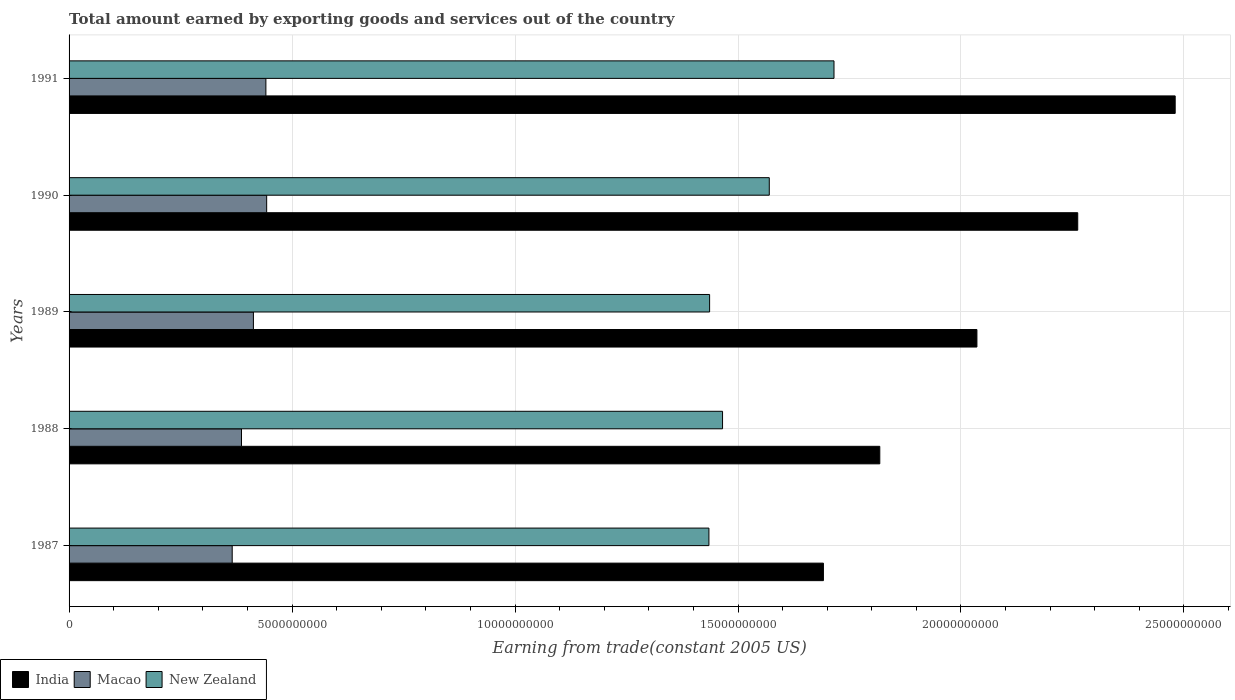How many different coloured bars are there?
Your response must be concise. 3. How many groups of bars are there?
Provide a short and direct response. 5. How many bars are there on the 3rd tick from the bottom?
Ensure brevity in your answer.  3. What is the total amount earned by exporting goods and services in Macao in 1989?
Your answer should be very brief. 4.13e+09. Across all years, what is the maximum total amount earned by exporting goods and services in Macao?
Make the answer very short. 4.43e+09. Across all years, what is the minimum total amount earned by exporting goods and services in New Zealand?
Make the answer very short. 1.43e+1. In which year was the total amount earned by exporting goods and services in Macao maximum?
Keep it short and to the point. 1990. In which year was the total amount earned by exporting goods and services in New Zealand minimum?
Offer a very short reply. 1987. What is the total total amount earned by exporting goods and services in Macao in the graph?
Give a very brief answer. 2.05e+1. What is the difference between the total amount earned by exporting goods and services in India in 1987 and that in 1990?
Keep it short and to the point. -5.70e+09. What is the difference between the total amount earned by exporting goods and services in Macao in 1991 and the total amount earned by exporting goods and services in New Zealand in 1989?
Your response must be concise. -9.95e+09. What is the average total amount earned by exporting goods and services in New Zealand per year?
Your answer should be compact. 1.52e+1. In the year 1987, what is the difference between the total amount earned by exporting goods and services in New Zealand and total amount earned by exporting goods and services in Macao?
Provide a short and direct response. 1.07e+1. What is the ratio of the total amount earned by exporting goods and services in New Zealand in 1989 to that in 1991?
Ensure brevity in your answer.  0.84. Is the total amount earned by exporting goods and services in India in 1987 less than that in 1989?
Provide a succinct answer. Yes. What is the difference between the highest and the second highest total amount earned by exporting goods and services in Macao?
Give a very brief answer. 1.77e+07. What is the difference between the highest and the lowest total amount earned by exporting goods and services in New Zealand?
Provide a short and direct response. 2.80e+09. In how many years, is the total amount earned by exporting goods and services in India greater than the average total amount earned by exporting goods and services in India taken over all years?
Provide a short and direct response. 2. Is the sum of the total amount earned by exporting goods and services in New Zealand in 1987 and 1990 greater than the maximum total amount earned by exporting goods and services in Macao across all years?
Give a very brief answer. Yes. What does the 3rd bar from the bottom in 1991 represents?
Your response must be concise. New Zealand. Are all the bars in the graph horizontal?
Offer a terse response. Yes. How many years are there in the graph?
Ensure brevity in your answer.  5. What is the difference between two consecutive major ticks on the X-axis?
Keep it short and to the point. 5.00e+09. Are the values on the major ticks of X-axis written in scientific E-notation?
Your response must be concise. No. Where does the legend appear in the graph?
Make the answer very short. Bottom left. How are the legend labels stacked?
Offer a very short reply. Horizontal. What is the title of the graph?
Your response must be concise. Total amount earned by exporting goods and services out of the country. Does "Heavily indebted poor countries" appear as one of the legend labels in the graph?
Ensure brevity in your answer.  No. What is the label or title of the X-axis?
Provide a succinct answer. Earning from trade(constant 2005 US). What is the Earning from trade(constant 2005 US) in India in 1987?
Your answer should be compact. 1.69e+1. What is the Earning from trade(constant 2005 US) in Macao in 1987?
Give a very brief answer. 3.66e+09. What is the Earning from trade(constant 2005 US) in New Zealand in 1987?
Your answer should be compact. 1.43e+1. What is the Earning from trade(constant 2005 US) in India in 1988?
Your answer should be compact. 1.82e+1. What is the Earning from trade(constant 2005 US) in Macao in 1988?
Ensure brevity in your answer.  3.87e+09. What is the Earning from trade(constant 2005 US) in New Zealand in 1988?
Provide a succinct answer. 1.47e+1. What is the Earning from trade(constant 2005 US) in India in 1989?
Your answer should be very brief. 2.04e+1. What is the Earning from trade(constant 2005 US) of Macao in 1989?
Offer a very short reply. 4.13e+09. What is the Earning from trade(constant 2005 US) of New Zealand in 1989?
Provide a succinct answer. 1.44e+1. What is the Earning from trade(constant 2005 US) in India in 1990?
Offer a terse response. 2.26e+1. What is the Earning from trade(constant 2005 US) in Macao in 1990?
Provide a succinct answer. 4.43e+09. What is the Earning from trade(constant 2005 US) in New Zealand in 1990?
Your answer should be very brief. 1.57e+1. What is the Earning from trade(constant 2005 US) in India in 1991?
Ensure brevity in your answer.  2.48e+1. What is the Earning from trade(constant 2005 US) of Macao in 1991?
Your response must be concise. 4.41e+09. What is the Earning from trade(constant 2005 US) of New Zealand in 1991?
Provide a succinct answer. 1.72e+1. Across all years, what is the maximum Earning from trade(constant 2005 US) in India?
Make the answer very short. 2.48e+1. Across all years, what is the maximum Earning from trade(constant 2005 US) of Macao?
Give a very brief answer. 4.43e+09. Across all years, what is the maximum Earning from trade(constant 2005 US) of New Zealand?
Your answer should be compact. 1.72e+1. Across all years, what is the minimum Earning from trade(constant 2005 US) of India?
Keep it short and to the point. 1.69e+1. Across all years, what is the minimum Earning from trade(constant 2005 US) in Macao?
Provide a succinct answer. 3.66e+09. Across all years, what is the minimum Earning from trade(constant 2005 US) in New Zealand?
Make the answer very short. 1.43e+1. What is the total Earning from trade(constant 2005 US) of India in the graph?
Provide a succinct answer. 1.03e+11. What is the total Earning from trade(constant 2005 US) of Macao in the graph?
Offer a terse response. 2.05e+1. What is the total Earning from trade(constant 2005 US) in New Zealand in the graph?
Your response must be concise. 7.62e+1. What is the difference between the Earning from trade(constant 2005 US) of India in 1987 and that in 1988?
Keep it short and to the point. -1.26e+09. What is the difference between the Earning from trade(constant 2005 US) in Macao in 1987 and that in 1988?
Ensure brevity in your answer.  -2.09e+08. What is the difference between the Earning from trade(constant 2005 US) in New Zealand in 1987 and that in 1988?
Offer a terse response. -3.05e+08. What is the difference between the Earning from trade(constant 2005 US) of India in 1987 and that in 1989?
Your answer should be compact. -3.44e+09. What is the difference between the Earning from trade(constant 2005 US) of Macao in 1987 and that in 1989?
Offer a terse response. -4.75e+08. What is the difference between the Earning from trade(constant 2005 US) of New Zealand in 1987 and that in 1989?
Your answer should be very brief. -1.52e+07. What is the difference between the Earning from trade(constant 2005 US) of India in 1987 and that in 1990?
Your answer should be very brief. -5.70e+09. What is the difference between the Earning from trade(constant 2005 US) of Macao in 1987 and that in 1990?
Offer a very short reply. -7.73e+08. What is the difference between the Earning from trade(constant 2005 US) of New Zealand in 1987 and that in 1990?
Provide a short and direct response. -1.35e+09. What is the difference between the Earning from trade(constant 2005 US) of India in 1987 and that in 1991?
Provide a short and direct response. -7.89e+09. What is the difference between the Earning from trade(constant 2005 US) in Macao in 1987 and that in 1991?
Make the answer very short. -7.55e+08. What is the difference between the Earning from trade(constant 2005 US) in New Zealand in 1987 and that in 1991?
Provide a succinct answer. -2.80e+09. What is the difference between the Earning from trade(constant 2005 US) in India in 1988 and that in 1989?
Offer a terse response. -2.18e+09. What is the difference between the Earning from trade(constant 2005 US) of Macao in 1988 and that in 1989?
Provide a succinct answer. -2.67e+08. What is the difference between the Earning from trade(constant 2005 US) in New Zealand in 1988 and that in 1989?
Ensure brevity in your answer.  2.90e+08. What is the difference between the Earning from trade(constant 2005 US) of India in 1988 and that in 1990?
Make the answer very short. -4.44e+09. What is the difference between the Earning from trade(constant 2005 US) of Macao in 1988 and that in 1990?
Provide a short and direct response. -5.64e+08. What is the difference between the Earning from trade(constant 2005 US) of New Zealand in 1988 and that in 1990?
Offer a very short reply. -1.05e+09. What is the difference between the Earning from trade(constant 2005 US) in India in 1988 and that in 1991?
Keep it short and to the point. -6.62e+09. What is the difference between the Earning from trade(constant 2005 US) of Macao in 1988 and that in 1991?
Give a very brief answer. -5.47e+08. What is the difference between the Earning from trade(constant 2005 US) of New Zealand in 1988 and that in 1991?
Provide a succinct answer. -2.50e+09. What is the difference between the Earning from trade(constant 2005 US) of India in 1989 and that in 1990?
Your answer should be compact. -2.26e+09. What is the difference between the Earning from trade(constant 2005 US) of Macao in 1989 and that in 1990?
Provide a succinct answer. -2.98e+08. What is the difference between the Earning from trade(constant 2005 US) in New Zealand in 1989 and that in 1990?
Your answer should be compact. -1.34e+09. What is the difference between the Earning from trade(constant 2005 US) of India in 1989 and that in 1991?
Ensure brevity in your answer.  -4.45e+09. What is the difference between the Earning from trade(constant 2005 US) in Macao in 1989 and that in 1991?
Ensure brevity in your answer.  -2.80e+08. What is the difference between the Earning from trade(constant 2005 US) in New Zealand in 1989 and that in 1991?
Keep it short and to the point. -2.79e+09. What is the difference between the Earning from trade(constant 2005 US) of India in 1990 and that in 1991?
Provide a short and direct response. -2.19e+09. What is the difference between the Earning from trade(constant 2005 US) in Macao in 1990 and that in 1991?
Give a very brief answer. 1.77e+07. What is the difference between the Earning from trade(constant 2005 US) in New Zealand in 1990 and that in 1991?
Provide a short and direct response. -1.45e+09. What is the difference between the Earning from trade(constant 2005 US) of India in 1987 and the Earning from trade(constant 2005 US) of Macao in 1988?
Make the answer very short. 1.30e+1. What is the difference between the Earning from trade(constant 2005 US) in India in 1987 and the Earning from trade(constant 2005 US) in New Zealand in 1988?
Keep it short and to the point. 2.26e+09. What is the difference between the Earning from trade(constant 2005 US) in Macao in 1987 and the Earning from trade(constant 2005 US) in New Zealand in 1988?
Offer a terse response. -1.10e+1. What is the difference between the Earning from trade(constant 2005 US) of India in 1987 and the Earning from trade(constant 2005 US) of Macao in 1989?
Provide a short and direct response. 1.28e+1. What is the difference between the Earning from trade(constant 2005 US) in India in 1987 and the Earning from trade(constant 2005 US) in New Zealand in 1989?
Your answer should be compact. 2.55e+09. What is the difference between the Earning from trade(constant 2005 US) in Macao in 1987 and the Earning from trade(constant 2005 US) in New Zealand in 1989?
Give a very brief answer. -1.07e+1. What is the difference between the Earning from trade(constant 2005 US) of India in 1987 and the Earning from trade(constant 2005 US) of Macao in 1990?
Your answer should be very brief. 1.25e+1. What is the difference between the Earning from trade(constant 2005 US) in India in 1987 and the Earning from trade(constant 2005 US) in New Zealand in 1990?
Offer a terse response. 1.21e+09. What is the difference between the Earning from trade(constant 2005 US) in Macao in 1987 and the Earning from trade(constant 2005 US) in New Zealand in 1990?
Give a very brief answer. -1.20e+1. What is the difference between the Earning from trade(constant 2005 US) of India in 1987 and the Earning from trade(constant 2005 US) of Macao in 1991?
Provide a succinct answer. 1.25e+1. What is the difference between the Earning from trade(constant 2005 US) of India in 1987 and the Earning from trade(constant 2005 US) of New Zealand in 1991?
Give a very brief answer. -2.37e+08. What is the difference between the Earning from trade(constant 2005 US) in Macao in 1987 and the Earning from trade(constant 2005 US) in New Zealand in 1991?
Keep it short and to the point. -1.35e+1. What is the difference between the Earning from trade(constant 2005 US) of India in 1988 and the Earning from trade(constant 2005 US) of Macao in 1989?
Offer a very short reply. 1.40e+1. What is the difference between the Earning from trade(constant 2005 US) in India in 1988 and the Earning from trade(constant 2005 US) in New Zealand in 1989?
Give a very brief answer. 3.82e+09. What is the difference between the Earning from trade(constant 2005 US) in Macao in 1988 and the Earning from trade(constant 2005 US) in New Zealand in 1989?
Keep it short and to the point. -1.05e+1. What is the difference between the Earning from trade(constant 2005 US) of India in 1988 and the Earning from trade(constant 2005 US) of Macao in 1990?
Provide a succinct answer. 1.37e+1. What is the difference between the Earning from trade(constant 2005 US) of India in 1988 and the Earning from trade(constant 2005 US) of New Zealand in 1990?
Keep it short and to the point. 2.48e+09. What is the difference between the Earning from trade(constant 2005 US) in Macao in 1988 and the Earning from trade(constant 2005 US) in New Zealand in 1990?
Keep it short and to the point. -1.18e+1. What is the difference between the Earning from trade(constant 2005 US) in India in 1988 and the Earning from trade(constant 2005 US) in Macao in 1991?
Make the answer very short. 1.38e+1. What is the difference between the Earning from trade(constant 2005 US) of India in 1988 and the Earning from trade(constant 2005 US) of New Zealand in 1991?
Your answer should be very brief. 1.03e+09. What is the difference between the Earning from trade(constant 2005 US) of Macao in 1988 and the Earning from trade(constant 2005 US) of New Zealand in 1991?
Give a very brief answer. -1.33e+1. What is the difference between the Earning from trade(constant 2005 US) in India in 1989 and the Earning from trade(constant 2005 US) in Macao in 1990?
Offer a very short reply. 1.59e+1. What is the difference between the Earning from trade(constant 2005 US) in India in 1989 and the Earning from trade(constant 2005 US) in New Zealand in 1990?
Offer a terse response. 4.66e+09. What is the difference between the Earning from trade(constant 2005 US) of Macao in 1989 and the Earning from trade(constant 2005 US) of New Zealand in 1990?
Keep it short and to the point. -1.16e+1. What is the difference between the Earning from trade(constant 2005 US) in India in 1989 and the Earning from trade(constant 2005 US) in Macao in 1991?
Provide a succinct answer. 1.59e+1. What is the difference between the Earning from trade(constant 2005 US) in India in 1989 and the Earning from trade(constant 2005 US) in New Zealand in 1991?
Give a very brief answer. 3.20e+09. What is the difference between the Earning from trade(constant 2005 US) in Macao in 1989 and the Earning from trade(constant 2005 US) in New Zealand in 1991?
Keep it short and to the point. -1.30e+1. What is the difference between the Earning from trade(constant 2005 US) in India in 1990 and the Earning from trade(constant 2005 US) in Macao in 1991?
Provide a succinct answer. 1.82e+1. What is the difference between the Earning from trade(constant 2005 US) in India in 1990 and the Earning from trade(constant 2005 US) in New Zealand in 1991?
Your answer should be very brief. 5.47e+09. What is the difference between the Earning from trade(constant 2005 US) in Macao in 1990 and the Earning from trade(constant 2005 US) in New Zealand in 1991?
Your answer should be compact. -1.27e+1. What is the average Earning from trade(constant 2005 US) of India per year?
Offer a terse response. 2.06e+1. What is the average Earning from trade(constant 2005 US) of Macao per year?
Give a very brief answer. 4.10e+09. What is the average Earning from trade(constant 2005 US) of New Zealand per year?
Make the answer very short. 1.52e+1. In the year 1987, what is the difference between the Earning from trade(constant 2005 US) of India and Earning from trade(constant 2005 US) of Macao?
Provide a succinct answer. 1.33e+1. In the year 1987, what is the difference between the Earning from trade(constant 2005 US) in India and Earning from trade(constant 2005 US) in New Zealand?
Provide a succinct answer. 2.57e+09. In the year 1987, what is the difference between the Earning from trade(constant 2005 US) of Macao and Earning from trade(constant 2005 US) of New Zealand?
Ensure brevity in your answer.  -1.07e+1. In the year 1988, what is the difference between the Earning from trade(constant 2005 US) of India and Earning from trade(constant 2005 US) of Macao?
Your response must be concise. 1.43e+1. In the year 1988, what is the difference between the Earning from trade(constant 2005 US) of India and Earning from trade(constant 2005 US) of New Zealand?
Make the answer very short. 3.53e+09. In the year 1988, what is the difference between the Earning from trade(constant 2005 US) of Macao and Earning from trade(constant 2005 US) of New Zealand?
Provide a short and direct response. -1.08e+1. In the year 1989, what is the difference between the Earning from trade(constant 2005 US) in India and Earning from trade(constant 2005 US) in Macao?
Make the answer very short. 1.62e+1. In the year 1989, what is the difference between the Earning from trade(constant 2005 US) in India and Earning from trade(constant 2005 US) in New Zealand?
Provide a short and direct response. 5.99e+09. In the year 1989, what is the difference between the Earning from trade(constant 2005 US) of Macao and Earning from trade(constant 2005 US) of New Zealand?
Your response must be concise. -1.02e+1. In the year 1990, what is the difference between the Earning from trade(constant 2005 US) in India and Earning from trade(constant 2005 US) in Macao?
Make the answer very short. 1.82e+1. In the year 1990, what is the difference between the Earning from trade(constant 2005 US) of India and Earning from trade(constant 2005 US) of New Zealand?
Your response must be concise. 6.92e+09. In the year 1990, what is the difference between the Earning from trade(constant 2005 US) of Macao and Earning from trade(constant 2005 US) of New Zealand?
Offer a terse response. -1.13e+1. In the year 1991, what is the difference between the Earning from trade(constant 2005 US) in India and Earning from trade(constant 2005 US) in Macao?
Provide a succinct answer. 2.04e+1. In the year 1991, what is the difference between the Earning from trade(constant 2005 US) of India and Earning from trade(constant 2005 US) of New Zealand?
Make the answer very short. 7.65e+09. In the year 1991, what is the difference between the Earning from trade(constant 2005 US) in Macao and Earning from trade(constant 2005 US) in New Zealand?
Your answer should be compact. -1.27e+1. What is the ratio of the Earning from trade(constant 2005 US) in India in 1987 to that in 1988?
Give a very brief answer. 0.93. What is the ratio of the Earning from trade(constant 2005 US) in Macao in 1987 to that in 1988?
Give a very brief answer. 0.95. What is the ratio of the Earning from trade(constant 2005 US) in New Zealand in 1987 to that in 1988?
Your answer should be compact. 0.98. What is the ratio of the Earning from trade(constant 2005 US) in India in 1987 to that in 1989?
Offer a very short reply. 0.83. What is the ratio of the Earning from trade(constant 2005 US) of Macao in 1987 to that in 1989?
Your answer should be very brief. 0.89. What is the ratio of the Earning from trade(constant 2005 US) of New Zealand in 1987 to that in 1989?
Ensure brevity in your answer.  1. What is the ratio of the Earning from trade(constant 2005 US) of India in 1987 to that in 1990?
Offer a terse response. 0.75. What is the ratio of the Earning from trade(constant 2005 US) of Macao in 1987 to that in 1990?
Offer a terse response. 0.83. What is the ratio of the Earning from trade(constant 2005 US) in New Zealand in 1987 to that in 1990?
Keep it short and to the point. 0.91. What is the ratio of the Earning from trade(constant 2005 US) of India in 1987 to that in 1991?
Your response must be concise. 0.68. What is the ratio of the Earning from trade(constant 2005 US) of Macao in 1987 to that in 1991?
Your answer should be compact. 0.83. What is the ratio of the Earning from trade(constant 2005 US) in New Zealand in 1987 to that in 1991?
Offer a very short reply. 0.84. What is the ratio of the Earning from trade(constant 2005 US) of India in 1988 to that in 1989?
Your answer should be very brief. 0.89. What is the ratio of the Earning from trade(constant 2005 US) of Macao in 1988 to that in 1989?
Make the answer very short. 0.94. What is the ratio of the Earning from trade(constant 2005 US) of New Zealand in 1988 to that in 1989?
Make the answer very short. 1.02. What is the ratio of the Earning from trade(constant 2005 US) of India in 1988 to that in 1990?
Ensure brevity in your answer.  0.8. What is the ratio of the Earning from trade(constant 2005 US) of Macao in 1988 to that in 1990?
Your response must be concise. 0.87. What is the ratio of the Earning from trade(constant 2005 US) of New Zealand in 1988 to that in 1990?
Provide a succinct answer. 0.93. What is the ratio of the Earning from trade(constant 2005 US) in India in 1988 to that in 1991?
Provide a short and direct response. 0.73. What is the ratio of the Earning from trade(constant 2005 US) in Macao in 1988 to that in 1991?
Keep it short and to the point. 0.88. What is the ratio of the Earning from trade(constant 2005 US) in New Zealand in 1988 to that in 1991?
Offer a very short reply. 0.85. What is the ratio of the Earning from trade(constant 2005 US) of India in 1989 to that in 1990?
Keep it short and to the point. 0.9. What is the ratio of the Earning from trade(constant 2005 US) in Macao in 1989 to that in 1990?
Your answer should be very brief. 0.93. What is the ratio of the Earning from trade(constant 2005 US) in New Zealand in 1989 to that in 1990?
Ensure brevity in your answer.  0.91. What is the ratio of the Earning from trade(constant 2005 US) of India in 1989 to that in 1991?
Your response must be concise. 0.82. What is the ratio of the Earning from trade(constant 2005 US) in Macao in 1989 to that in 1991?
Give a very brief answer. 0.94. What is the ratio of the Earning from trade(constant 2005 US) in New Zealand in 1989 to that in 1991?
Give a very brief answer. 0.84. What is the ratio of the Earning from trade(constant 2005 US) of India in 1990 to that in 1991?
Provide a short and direct response. 0.91. What is the ratio of the Earning from trade(constant 2005 US) of New Zealand in 1990 to that in 1991?
Your response must be concise. 0.92. What is the difference between the highest and the second highest Earning from trade(constant 2005 US) in India?
Your answer should be very brief. 2.19e+09. What is the difference between the highest and the second highest Earning from trade(constant 2005 US) of Macao?
Your answer should be very brief. 1.77e+07. What is the difference between the highest and the second highest Earning from trade(constant 2005 US) in New Zealand?
Make the answer very short. 1.45e+09. What is the difference between the highest and the lowest Earning from trade(constant 2005 US) in India?
Provide a short and direct response. 7.89e+09. What is the difference between the highest and the lowest Earning from trade(constant 2005 US) in Macao?
Make the answer very short. 7.73e+08. What is the difference between the highest and the lowest Earning from trade(constant 2005 US) of New Zealand?
Provide a succinct answer. 2.80e+09. 